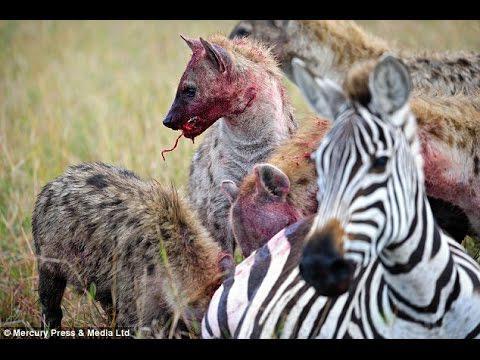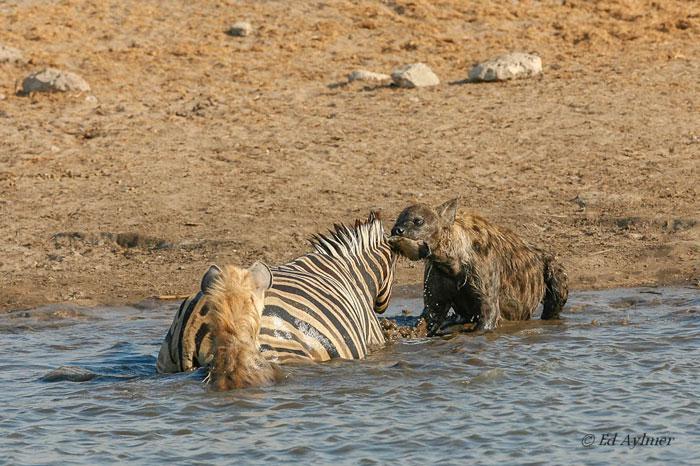The first image is the image on the left, the second image is the image on the right. Assess this claim about the two images: "A hyena attacks a zebra that is in the water.". Correct or not? Answer yes or no. Yes. 